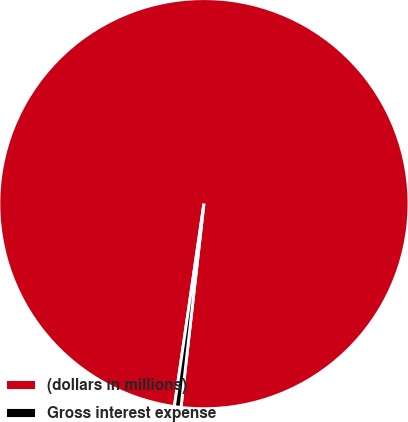Convert chart to OTSL. <chart><loc_0><loc_0><loc_500><loc_500><pie_chart><fcel>(dollars in millions)<fcel>Gross interest expense<nl><fcel>99.48%<fcel>0.52%<nl></chart> 